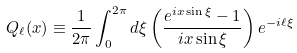Convert formula to latex. <formula><loc_0><loc_0><loc_500><loc_500>Q _ { \ell } ( x ) \equiv \frac { 1 } { 2 \pi } \int _ { 0 } ^ { 2 \pi } d \xi \left ( \frac { e ^ { i x \sin \xi } - 1 } { i x \sin \xi } \right ) e ^ { - i \ell \xi }</formula> 